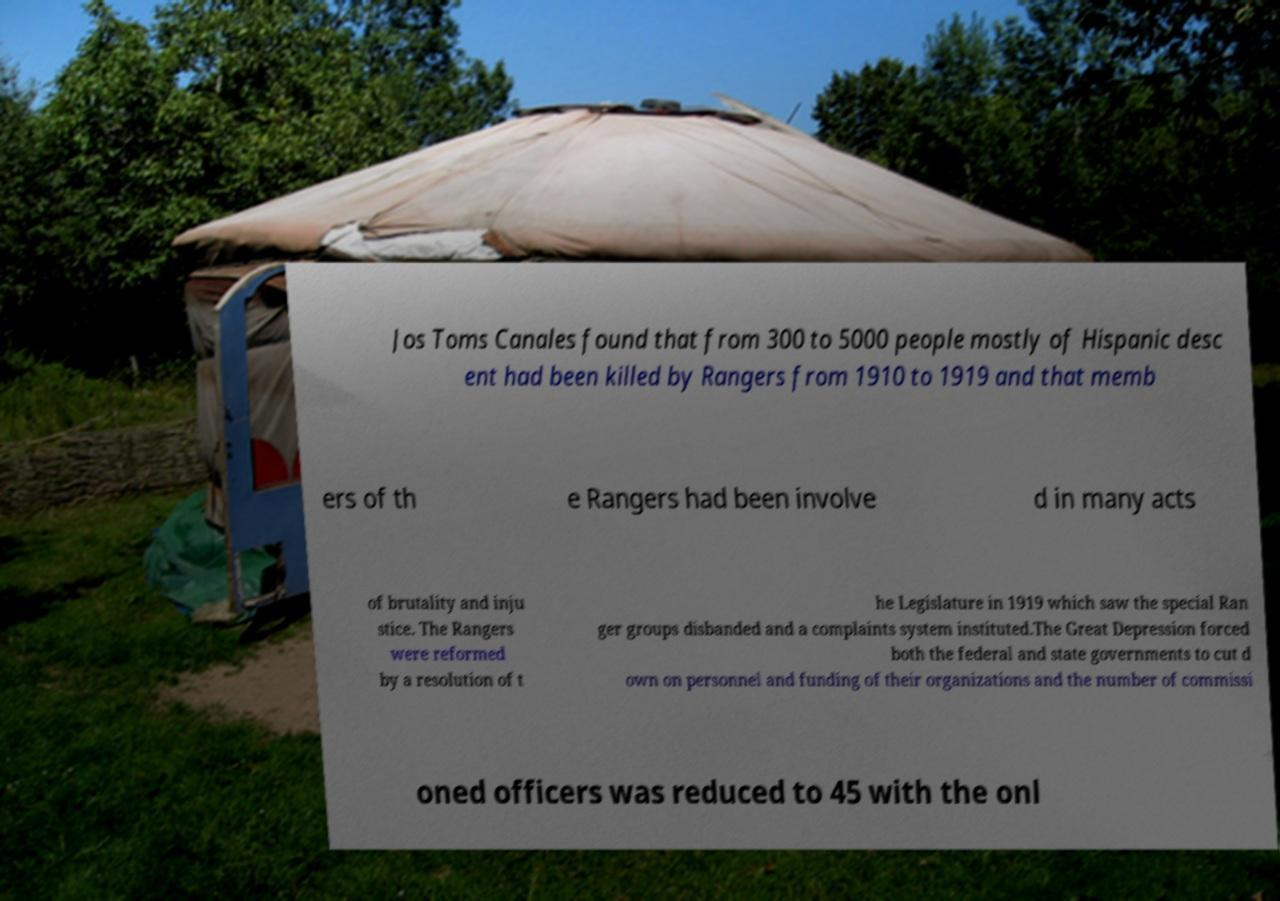Could you assist in decoding the text presented in this image and type it out clearly? Jos Toms Canales found that from 300 to 5000 people mostly of Hispanic desc ent had been killed by Rangers from 1910 to 1919 and that memb ers of th e Rangers had been involve d in many acts of brutality and inju stice. The Rangers were reformed by a resolution of t he Legislature in 1919 which saw the special Ran ger groups disbanded and a complaints system instituted.The Great Depression forced both the federal and state governments to cut d own on personnel and funding of their organizations and the number of commissi oned officers was reduced to 45 with the onl 